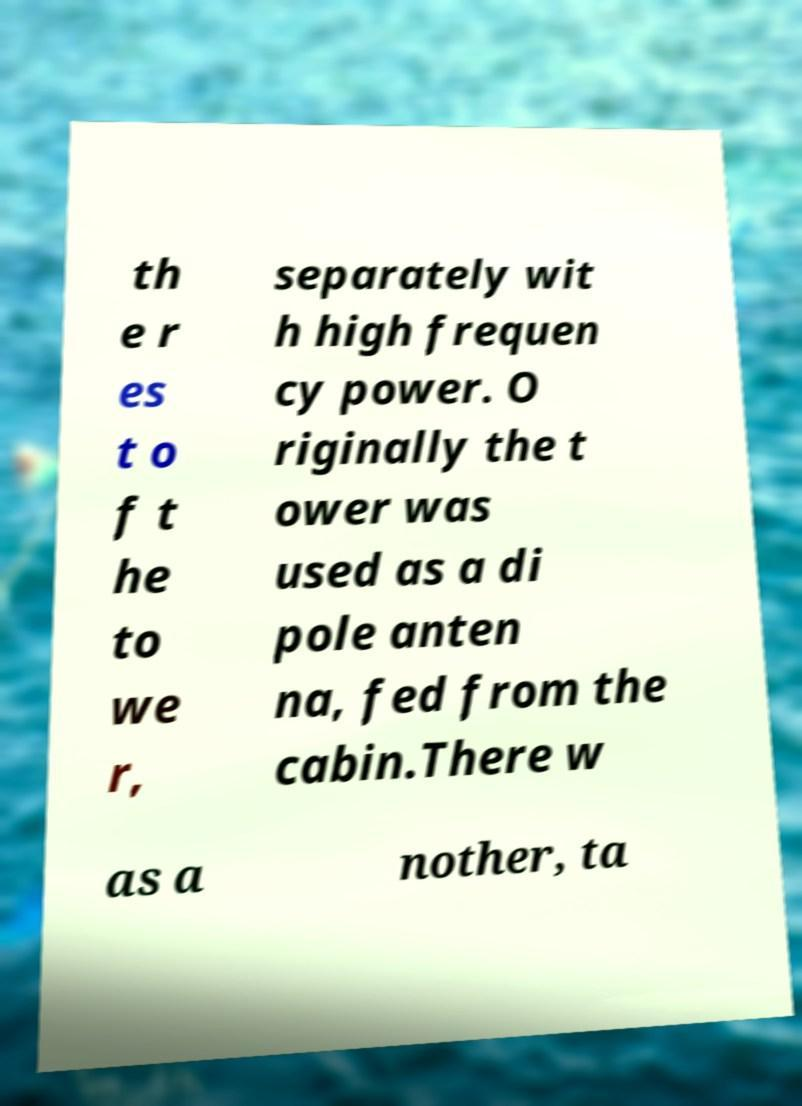Please read and relay the text visible in this image. What does it say? th e r es t o f t he to we r, separately wit h high frequen cy power. O riginally the t ower was used as a di pole anten na, fed from the cabin.There w as a nother, ta 